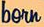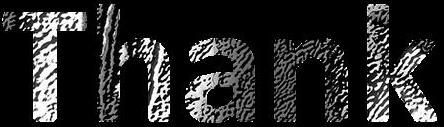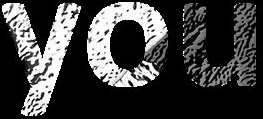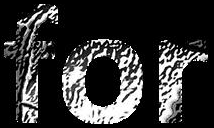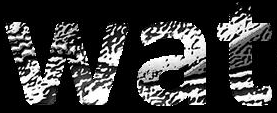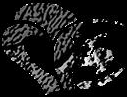What text is displayed in these images sequentially, separated by a semicolon? born; Thank; you; for; wat; # 